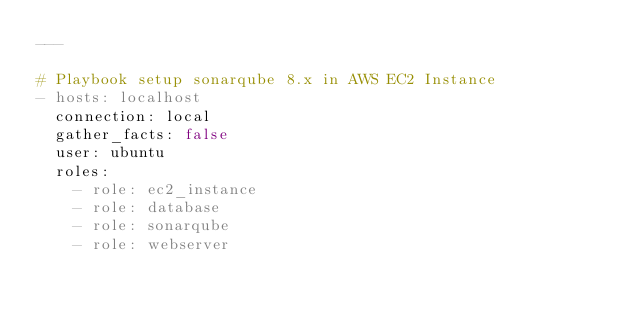<code> <loc_0><loc_0><loc_500><loc_500><_YAML_>---

# Playbook setup sonarqube 8.x in AWS EC2 Instance
- hosts: localhost
  connection: local
  gather_facts: false
  user: ubuntu
  roles:
    - role: ec2_instance
    - role: database
    - role: sonarqube
    - role: webserver</code> 